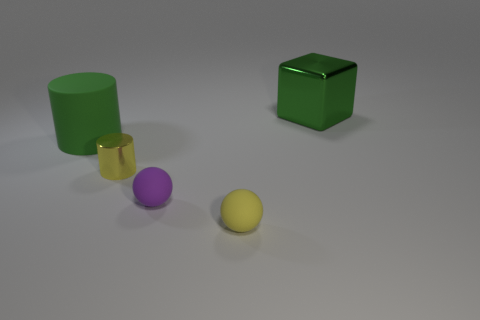What number of things are either tiny red balls or tiny yellow metallic cylinders on the left side of the tiny purple matte ball?
Provide a short and direct response. 1. What number of other things are there of the same shape as the tiny purple thing?
Offer a very short reply. 1. Does the big thing in front of the large green block have the same material as the green block?
Your answer should be very brief. No. How many things are either tiny purple metal cylinders or large green cubes?
Ensure brevity in your answer.  1. What size is the other thing that is the same shape as the small purple thing?
Make the answer very short. Small. How big is the green metal block?
Your answer should be very brief. Large. Are there more small metal objects behind the yellow cylinder than small gray matte cubes?
Offer a terse response. No. Is there any other thing that is the same material as the small purple thing?
Provide a succinct answer. Yes. There is a large object that is right of the green matte cylinder; is it the same color as the cylinder in front of the big cylinder?
Ensure brevity in your answer.  No. What material is the small yellow cylinder that is behind the small rubber ball to the right of the tiny rubber sphere that is on the left side of the yellow sphere made of?
Keep it short and to the point. Metal. 